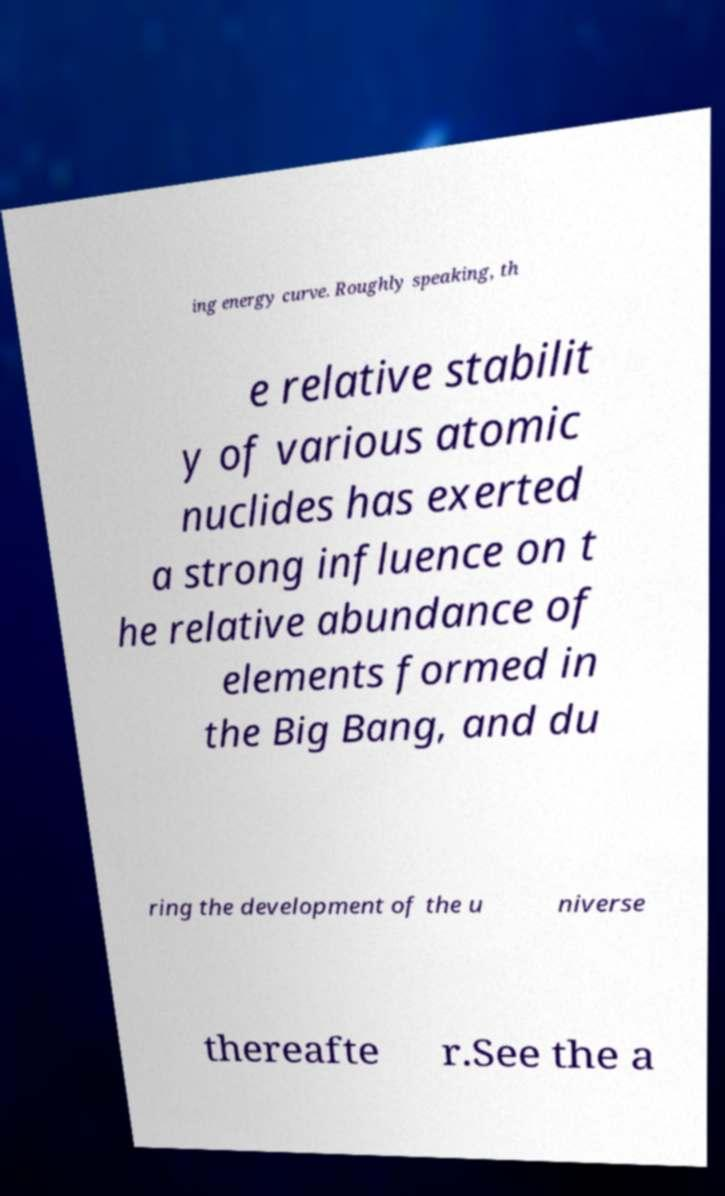Could you extract and type out the text from this image? ing energy curve. Roughly speaking, th e relative stabilit y of various atomic nuclides has exerted a strong influence on t he relative abundance of elements formed in the Big Bang, and du ring the development of the u niverse thereafte r.See the a 